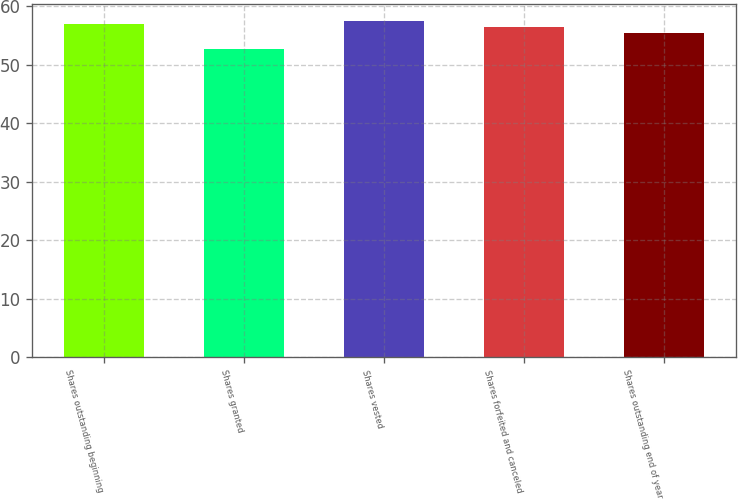<chart> <loc_0><loc_0><loc_500><loc_500><bar_chart><fcel>Shares outstanding beginning<fcel>Shares granted<fcel>Shares vested<fcel>Shares forfeited and canceled<fcel>Shares outstanding end of year<nl><fcel>57.08<fcel>52.72<fcel>57.52<fcel>56.44<fcel>55.5<nl></chart> 